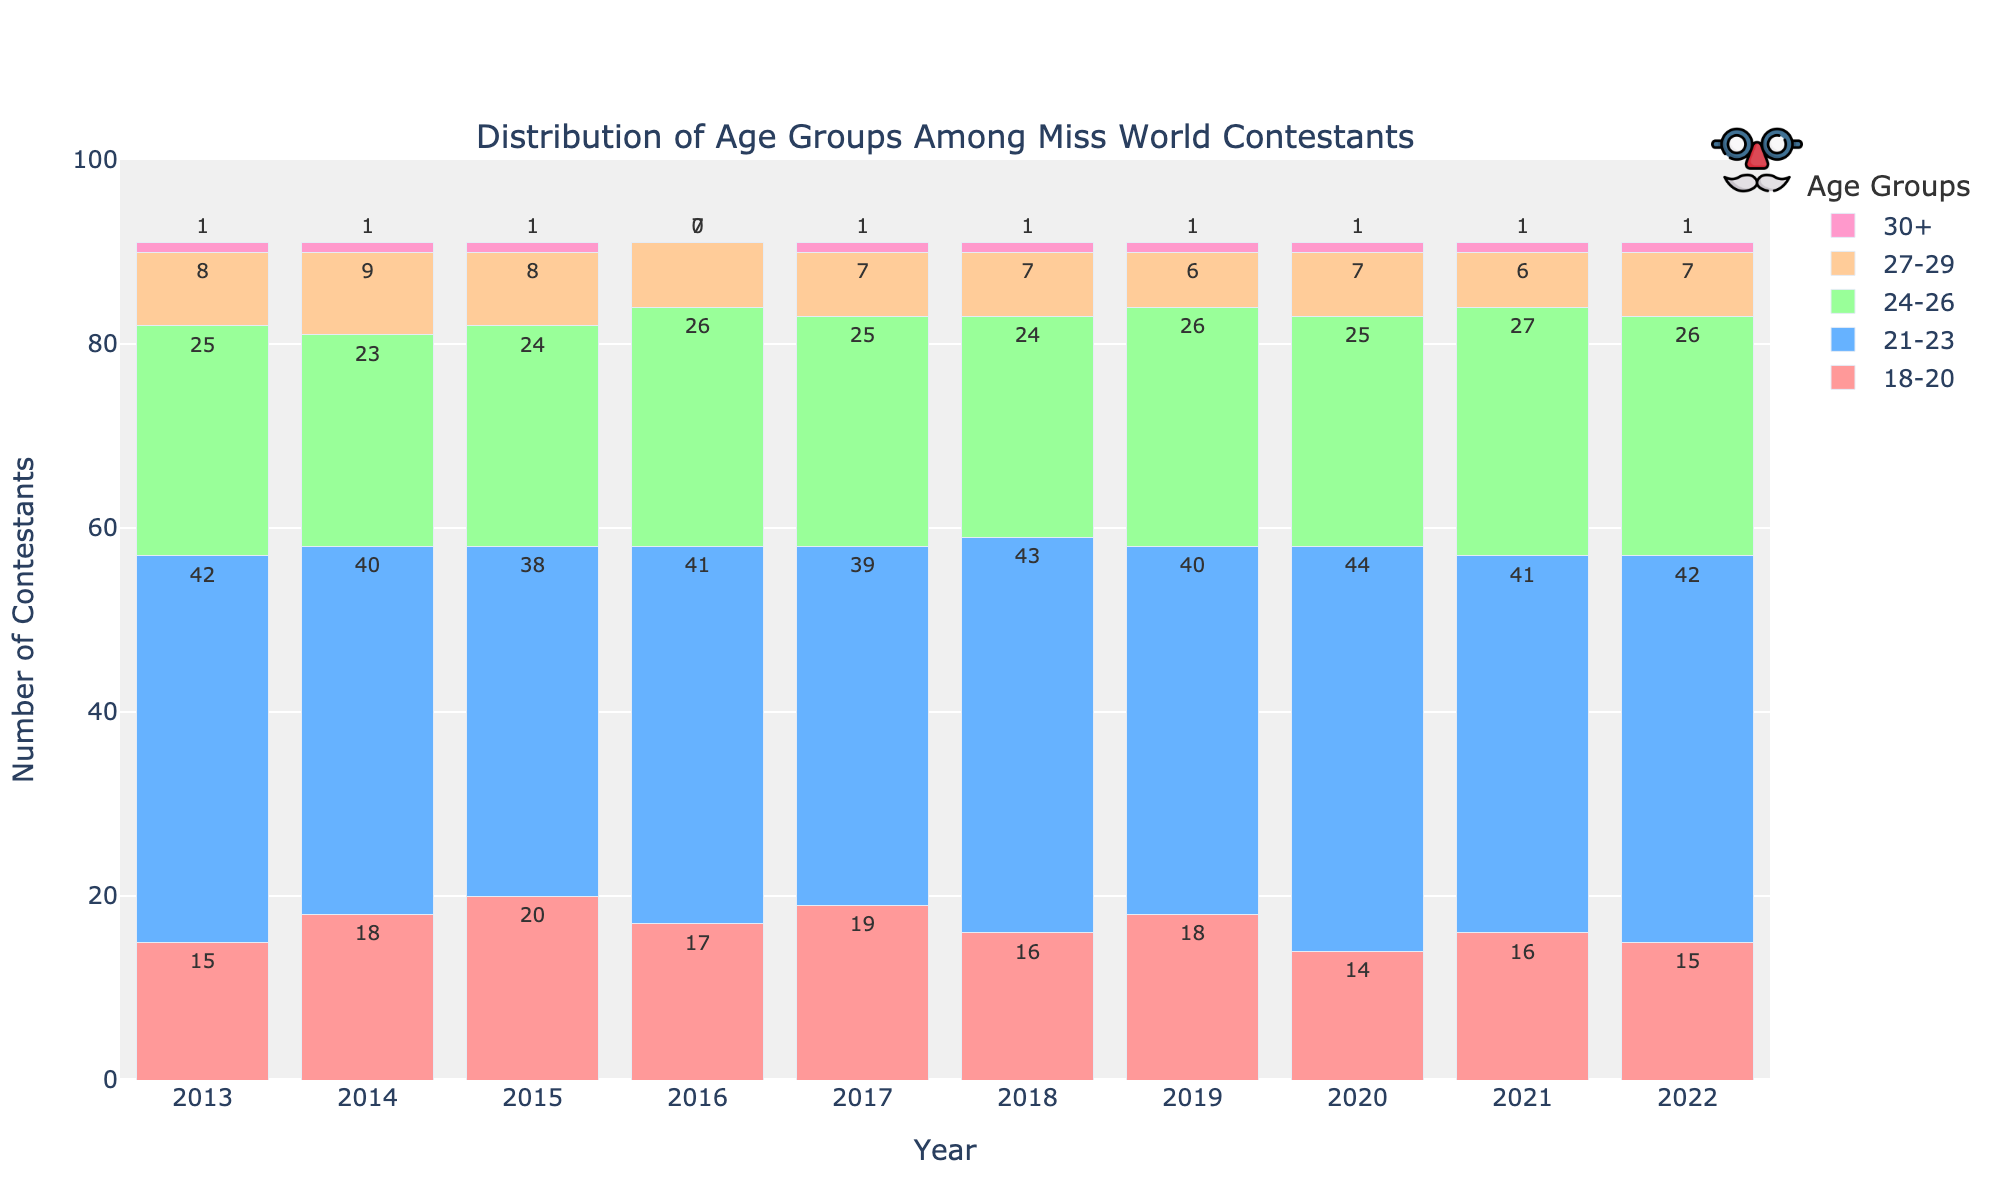what's the most frequent age group among contestants in 2019? From the bars representing the year 2019, the bar for the 21-23 age group is the highest. Hence, 21-23 is the most frequent age group among contestants in 2019.
Answer: 21-23 how many more contestants were there in the 18-20 age group than the 27-29 age group in 2014? In 2014, there were 18 contestants in the 18-20 age group and 9 contestants in the 27-29 age group. The difference is 18 - 9 = 9 contestants.
Answer: 9 what's the average number of contestants in the 24-26 age group from 2018 to 2022? The number of contestants in the 24-26 age group from 2018 to 2022 is 24, 26, 25, 27, and 26 respectively. The sum is 24 + 26 + 25 + 27 + 26 = 128. The average is 128 / 5 = 25.6 contestants.
Answer: 25.6 in which year did the 18-20 age group have the fewest contestants? Comparing the bars representing the 18-20 age group across all years, the lowest bar corresponds to the year 2020 with 14 contestants.
Answer: 2020 how many total contestants were there in the 30+ age group over the decade? The number of contestants in the 30+ age group each year is 1, 1, 1, 0, 1, 1, 1, 1, 1, and 1 respectively. The total is 1 + 1 + 1 + 0 + 1 + 1 + 1 + 1 + 1 + 1 = 9 contestants.
Answer: 9 did the 21-23 age group have more or fewer contestants in 2022 compared to 2016? The number of contestants in the 21-23 age group in 2022 is 42, whereas in 2016 it was 41. Since 42 > 41, there were more contestants in 2022 compared to 2016.
Answer: More what is the difference between the highest and lowest number of contestants for the 24-26 age group over the decade? Over the decade, the highest number of contestants in the 24-26 age group is 27 (2021) and the lowest is 23 (2014). The difference is 27 - 23 = 4 contestants.
Answer: 4 which age group has the bar with the color red? Observing the colors of the bars, the smallest age group (18-20) has the color red.
Answer: 18-20 